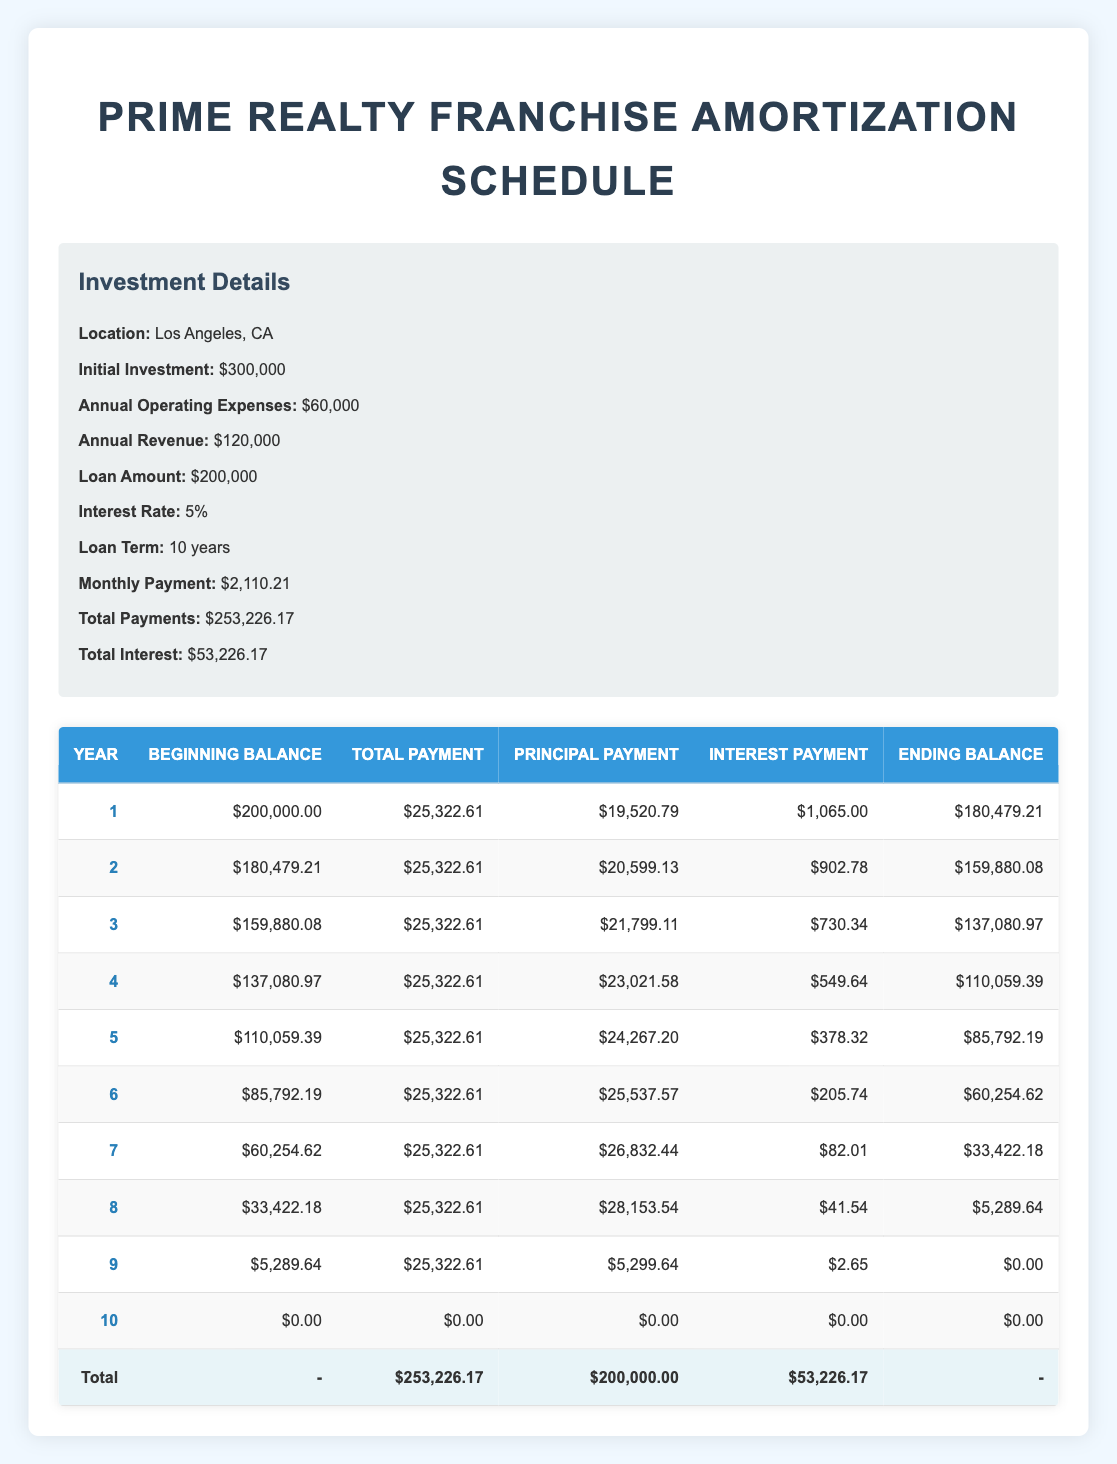What is the total payment made in the first year? The table indicates that the total payment for year 1 is listed in the "Total Payment" column for that year. It is 25,322.61.
Answer: 25,322.61 What is the ending balance at the end of year 3? To find the ending balance for year 3, we look at the "Ending Balance" column, which shows the value for year 3 as 137,080.97.
Answer: 137,080.97 What is the total amount of principal paid over the 10 years? We need to sum the "Principal Payment" values from year 1 to year 9 (since year 10 shows zero). Adding these gives us: 19,520.79 + 20,599.13 + 21,799.11 + 23,021.58 + 24,267.20 + 25,537.57 + 26,832.44 + 28,153.54 + 5,299.64 = 200,000.00.
Answer: 200,000.00 Did the interest payment in year 6 exceed 200? In year 6, the interest payment is listed as 205.74. Since we are comparing it against 200, we can conclude that it indeed exceeds this amount.
Answer: Yes What was the annual operating expense as a percentage of annual revenue? To find the percentage, we take the annual operating expenses of 60,000 and divide it by the annual revenue of 120,000. Then we multiply by 100: (60,000 / 120,000) * 100 = 50%.
Answer: 50% What year had the highest principal payment, and what was the amount? We need to identify the maximum value in the "Principal Payment" column. Year 5 has a principal payment of 24,267.20 which is the highest value seen in the table for principal payments, hence it is the answer.
Answer: Year 5, 24,267.20 What was the payment during the first half of the loan term compared to the second half? The total payments for the first five years can be calculated by summing the "Total Payment" values from year 1 to year 5, which gives 25,322.61 * 5 = 126,613.05. For the last five years, it's the same amount, so the payment remains consistent.
Answer: Equal What is the average interest payment over the loan term? To find the average, we sum the interest payments for years 1 to 9 (1,065.00 + 902.78 + 730.34 + 549.64 + 378.32 + 205.74 + 82.01 + 41.54 + 2.65 = 2,932.38) and divide it by the number of years (9), resulting in 2,932.38 / 9 = 326.93.
Answer: 326.93 